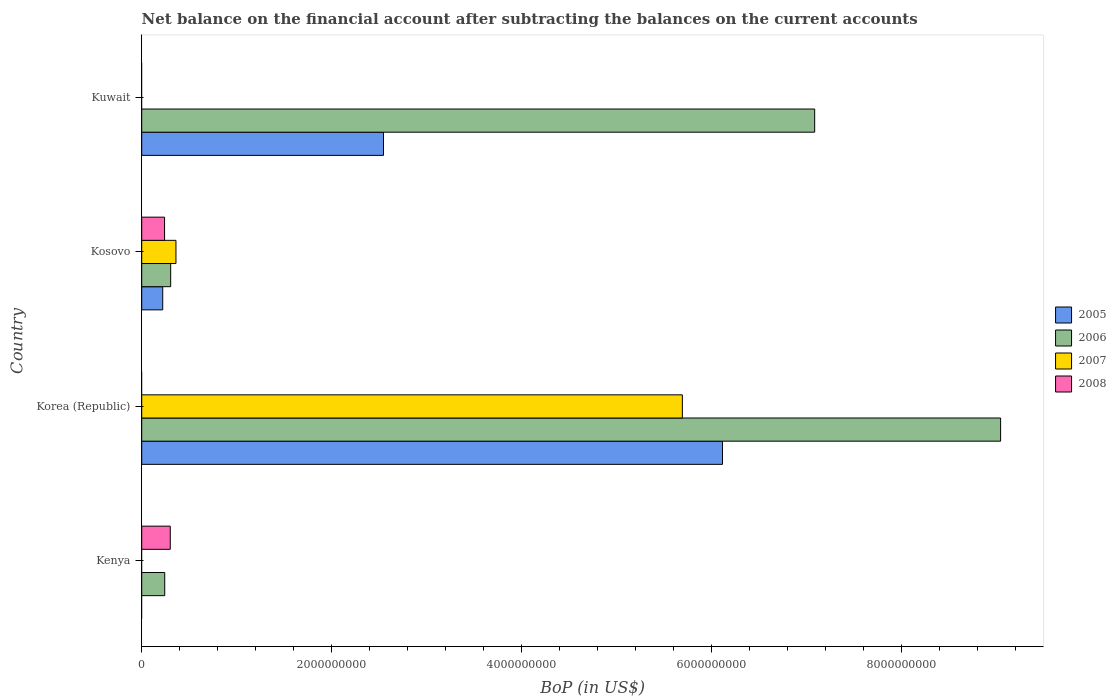Are the number of bars per tick equal to the number of legend labels?
Make the answer very short. No. Are the number of bars on each tick of the Y-axis equal?
Offer a terse response. No. What is the label of the 1st group of bars from the top?
Provide a short and direct response. Kuwait. In how many cases, is the number of bars for a given country not equal to the number of legend labels?
Make the answer very short. 3. What is the Balance of Payments in 2005 in Korea (Republic)?
Offer a very short reply. 6.12e+09. Across all countries, what is the maximum Balance of Payments in 2008?
Your answer should be compact. 3.01e+08. Across all countries, what is the minimum Balance of Payments in 2005?
Your answer should be very brief. 0. In which country was the Balance of Payments in 2006 maximum?
Your answer should be compact. Korea (Republic). What is the total Balance of Payments in 2007 in the graph?
Offer a terse response. 6.05e+09. What is the difference between the Balance of Payments in 2005 in Kosovo and that in Kuwait?
Give a very brief answer. -2.33e+09. What is the difference between the Balance of Payments in 2005 in Kosovo and the Balance of Payments in 2007 in Kenya?
Make the answer very short. 2.21e+08. What is the average Balance of Payments in 2008 per country?
Ensure brevity in your answer.  1.35e+08. What is the difference between the Balance of Payments in 2006 and Balance of Payments in 2008 in Kenya?
Your answer should be very brief. -5.82e+07. In how many countries, is the Balance of Payments in 2008 greater than 2800000000 US$?
Offer a very short reply. 0. What is the ratio of the Balance of Payments in 2006 in Kosovo to that in Kuwait?
Provide a short and direct response. 0.04. Is the Balance of Payments in 2008 in Kenya less than that in Kosovo?
Give a very brief answer. No. What is the difference between the highest and the second highest Balance of Payments in 2005?
Give a very brief answer. 3.57e+09. What is the difference between the highest and the lowest Balance of Payments in 2006?
Give a very brief answer. 8.80e+09. In how many countries, is the Balance of Payments in 2008 greater than the average Balance of Payments in 2008 taken over all countries?
Provide a short and direct response. 2. Is it the case that in every country, the sum of the Balance of Payments in 2007 and Balance of Payments in 2006 is greater than the Balance of Payments in 2008?
Your answer should be compact. No. Does the graph contain any zero values?
Keep it short and to the point. Yes. Where does the legend appear in the graph?
Give a very brief answer. Center right. How are the legend labels stacked?
Offer a terse response. Vertical. What is the title of the graph?
Offer a terse response. Net balance on the financial account after subtracting the balances on the current accounts. What is the label or title of the X-axis?
Provide a succinct answer. BoP (in US$). What is the label or title of the Y-axis?
Provide a short and direct response. Country. What is the BoP (in US$) in 2006 in Kenya?
Your answer should be very brief. 2.42e+08. What is the BoP (in US$) of 2007 in Kenya?
Your answer should be compact. 0. What is the BoP (in US$) in 2008 in Kenya?
Offer a very short reply. 3.01e+08. What is the BoP (in US$) of 2005 in Korea (Republic)?
Make the answer very short. 6.12e+09. What is the BoP (in US$) of 2006 in Korea (Republic)?
Your answer should be compact. 9.05e+09. What is the BoP (in US$) in 2007 in Korea (Republic)?
Give a very brief answer. 5.69e+09. What is the BoP (in US$) in 2008 in Korea (Republic)?
Ensure brevity in your answer.  0. What is the BoP (in US$) of 2005 in Kosovo?
Your response must be concise. 2.21e+08. What is the BoP (in US$) in 2006 in Kosovo?
Keep it short and to the point. 3.05e+08. What is the BoP (in US$) of 2007 in Kosovo?
Your response must be concise. 3.60e+08. What is the BoP (in US$) in 2008 in Kosovo?
Offer a very short reply. 2.41e+08. What is the BoP (in US$) of 2005 in Kuwait?
Make the answer very short. 2.55e+09. What is the BoP (in US$) of 2006 in Kuwait?
Your answer should be compact. 7.09e+09. Across all countries, what is the maximum BoP (in US$) in 2005?
Your answer should be compact. 6.12e+09. Across all countries, what is the maximum BoP (in US$) of 2006?
Provide a succinct answer. 9.05e+09. Across all countries, what is the maximum BoP (in US$) in 2007?
Your answer should be very brief. 5.69e+09. Across all countries, what is the maximum BoP (in US$) in 2008?
Your answer should be very brief. 3.01e+08. Across all countries, what is the minimum BoP (in US$) of 2005?
Ensure brevity in your answer.  0. Across all countries, what is the minimum BoP (in US$) in 2006?
Provide a short and direct response. 2.42e+08. Across all countries, what is the minimum BoP (in US$) of 2007?
Make the answer very short. 0. What is the total BoP (in US$) of 2005 in the graph?
Offer a terse response. 8.88e+09. What is the total BoP (in US$) of 2006 in the graph?
Your answer should be very brief. 1.67e+1. What is the total BoP (in US$) of 2007 in the graph?
Offer a very short reply. 6.05e+09. What is the total BoP (in US$) of 2008 in the graph?
Provide a succinct answer. 5.41e+08. What is the difference between the BoP (in US$) of 2006 in Kenya and that in Korea (Republic)?
Give a very brief answer. -8.80e+09. What is the difference between the BoP (in US$) of 2006 in Kenya and that in Kosovo?
Your answer should be very brief. -6.26e+07. What is the difference between the BoP (in US$) of 2008 in Kenya and that in Kosovo?
Provide a short and direct response. 5.99e+07. What is the difference between the BoP (in US$) in 2006 in Kenya and that in Kuwait?
Offer a very short reply. -6.84e+09. What is the difference between the BoP (in US$) in 2005 in Korea (Republic) and that in Kosovo?
Your response must be concise. 5.90e+09. What is the difference between the BoP (in US$) of 2006 in Korea (Republic) and that in Kosovo?
Give a very brief answer. 8.74e+09. What is the difference between the BoP (in US$) in 2007 in Korea (Republic) and that in Kosovo?
Ensure brevity in your answer.  5.33e+09. What is the difference between the BoP (in US$) in 2005 in Korea (Republic) and that in Kuwait?
Offer a terse response. 3.57e+09. What is the difference between the BoP (in US$) of 2006 in Korea (Republic) and that in Kuwait?
Your answer should be compact. 1.96e+09. What is the difference between the BoP (in US$) in 2005 in Kosovo and that in Kuwait?
Offer a terse response. -2.33e+09. What is the difference between the BoP (in US$) in 2006 in Kosovo and that in Kuwait?
Make the answer very short. -6.78e+09. What is the difference between the BoP (in US$) in 2006 in Kenya and the BoP (in US$) in 2007 in Korea (Republic)?
Make the answer very short. -5.45e+09. What is the difference between the BoP (in US$) in 2006 in Kenya and the BoP (in US$) in 2007 in Kosovo?
Give a very brief answer. -1.18e+08. What is the difference between the BoP (in US$) in 2006 in Kenya and the BoP (in US$) in 2008 in Kosovo?
Give a very brief answer. 1.71e+06. What is the difference between the BoP (in US$) of 2005 in Korea (Republic) and the BoP (in US$) of 2006 in Kosovo?
Offer a very short reply. 5.81e+09. What is the difference between the BoP (in US$) in 2005 in Korea (Republic) and the BoP (in US$) in 2007 in Kosovo?
Give a very brief answer. 5.76e+09. What is the difference between the BoP (in US$) in 2005 in Korea (Republic) and the BoP (in US$) in 2008 in Kosovo?
Ensure brevity in your answer.  5.88e+09. What is the difference between the BoP (in US$) in 2006 in Korea (Republic) and the BoP (in US$) in 2007 in Kosovo?
Make the answer very short. 8.68e+09. What is the difference between the BoP (in US$) in 2006 in Korea (Republic) and the BoP (in US$) in 2008 in Kosovo?
Ensure brevity in your answer.  8.80e+09. What is the difference between the BoP (in US$) of 2007 in Korea (Republic) and the BoP (in US$) of 2008 in Kosovo?
Provide a short and direct response. 5.45e+09. What is the difference between the BoP (in US$) in 2005 in Korea (Republic) and the BoP (in US$) in 2006 in Kuwait?
Offer a very short reply. -9.71e+08. What is the difference between the BoP (in US$) of 2005 in Kosovo and the BoP (in US$) of 2006 in Kuwait?
Make the answer very short. -6.87e+09. What is the average BoP (in US$) in 2005 per country?
Keep it short and to the point. 2.22e+09. What is the average BoP (in US$) in 2006 per country?
Ensure brevity in your answer.  4.17e+09. What is the average BoP (in US$) in 2007 per country?
Your answer should be compact. 1.51e+09. What is the average BoP (in US$) of 2008 per country?
Ensure brevity in your answer.  1.35e+08. What is the difference between the BoP (in US$) in 2006 and BoP (in US$) in 2008 in Kenya?
Keep it short and to the point. -5.82e+07. What is the difference between the BoP (in US$) of 2005 and BoP (in US$) of 2006 in Korea (Republic)?
Your answer should be compact. -2.93e+09. What is the difference between the BoP (in US$) of 2005 and BoP (in US$) of 2007 in Korea (Republic)?
Make the answer very short. 4.23e+08. What is the difference between the BoP (in US$) of 2006 and BoP (in US$) of 2007 in Korea (Republic)?
Provide a short and direct response. 3.35e+09. What is the difference between the BoP (in US$) of 2005 and BoP (in US$) of 2006 in Kosovo?
Your response must be concise. -8.37e+07. What is the difference between the BoP (in US$) in 2005 and BoP (in US$) in 2007 in Kosovo?
Keep it short and to the point. -1.39e+08. What is the difference between the BoP (in US$) of 2005 and BoP (in US$) of 2008 in Kosovo?
Keep it short and to the point. -1.93e+07. What is the difference between the BoP (in US$) of 2006 and BoP (in US$) of 2007 in Kosovo?
Offer a terse response. -5.55e+07. What is the difference between the BoP (in US$) in 2006 and BoP (in US$) in 2008 in Kosovo?
Your answer should be very brief. 6.44e+07. What is the difference between the BoP (in US$) of 2007 and BoP (in US$) of 2008 in Kosovo?
Ensure brevity in your answer.  1.20e+08. What is the difference between the BoP (in US$) of 2005 and BoP (in US$) of 2006 in Kuwait?
Your answer should be compact. -4.54e+09. What is the ratio of the BoP (in US$) in 2006 in Kenya to that in Korea (Republic)?
Offer a very short reply. 0.03. What is the ratio of the BoP (in US$) of 2006 in Kenya to that in Kosovo?
Provide a succinct answer. 0.79. What is the ratio of the BoP (in US$) in 2008 in Kenya to that in Kosovo?
Your response must be concise. 1.25. What is the ratio of the BoP (in US$) in 2006 in Kenya to that in Kuwait?
Give a very brief answer. 0.03. What is the ratio of the BoP (in US$) in 2005 in Korea (Republic) to that in Kosovo?
Keep it short and to the point. 27.65. What is the ratio of the BoP (in US$) of 2006 in Korea (Republic) to that in Kosovo?
Your answer should be very brief. 29.66. What is the ratio of the BoP (in US$) of 2007 in Korea (Republic) to that in Kosovo?
Make the answer very short. 15.8. What is the ratio of the BoP (in US$) of 2005 in Korea (Republic) to that in Kuwait?
Offer a terse response. 2.4. What is the ratio of the BoP (in US$) of 2006 in Korea (Republic) to that in Kuwait?
Provide a succinct answer. 1.28. What is the ratio of the BoP (in US$) of 2005 in Kosovo to that in Kuwait?
Your answer should be very brief. 0.09. What is the ratio of the BoP (in US$) in 2006 in Kosovo to that in Kuwait?
Provide a short and direct response. 0.04. What is the difference between the highest and the second highest BoP (in US$) in 2005?
Ensure brevity in your answer.  3.57e+09. What is the difference between the highest and the second highest BoP (in US$) of 2006?
Make the answer very short. 1.96e+09. What is the difference between the highest and the lowest BoP (in US$) in 2005?
Provide a succinct answer. 6.12e+09. What is the difference between the highest and the lowest BoP (in US$) in 2006?
Give a very brief answer. 8.80e+09. What is the difference between the highest and the lowest BoP (in US$) in 2007?
Make the answer very short. 5.69e+09. What is the difference between the highest and the lowest BoP (in US$) of 2008?
Your answer should be compact. 3.01e+08. 